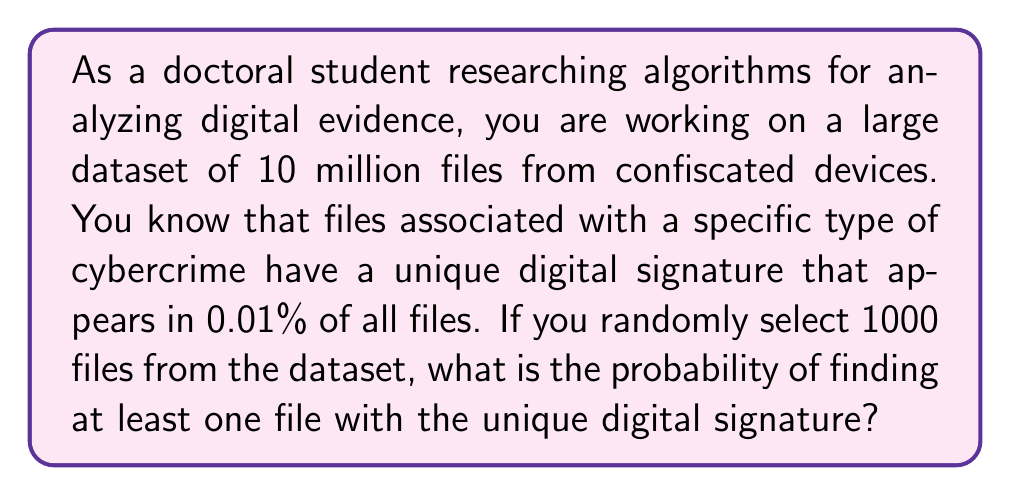Give your solution to this math problem. To solve this problem, we'll use the following steps:

1) First, let's identify the probability of a single file having the unique digital signature:
   $p = 0.0001$ (0.01% expressed as a decimal)

2) The probability of a file not having the signature is:
   $q = 1 - p = 0.9999$

3) We want to find the probability of at least one file in 1000 having the signature. This is equivalent to 1 minus the probability of no files having the signature.

4) The probability of no files having the signature in 1000 trials is:
   $P(\text{no signature}) = q^{1000} = 0.9999^{1000}$

5) Therefore, the probability of at least one file having the signature is:
   $P(\text{at least one}) = 1 - P(\text{no signature}) = 1 - 0.9999^{1000}$

6) We can calculate this using a calculator or computer:

   $$\begin{align}
   P(\text{at least one}) &= 1 - 0.9999^{1000} \\
   &= 1 - 0.9048374180359595 \\
   &= 0.0951625819640405
   \end{align}$$

7) Converting to a percentage:
   $0.0951625819640405 \times 100\% = 9.52\%$ (rounded to two decimal places)
Answer: The probability of finding at least one file with the unique digital signature when randomly selecting 1000 files from the dataset is approximately 9.52%. 